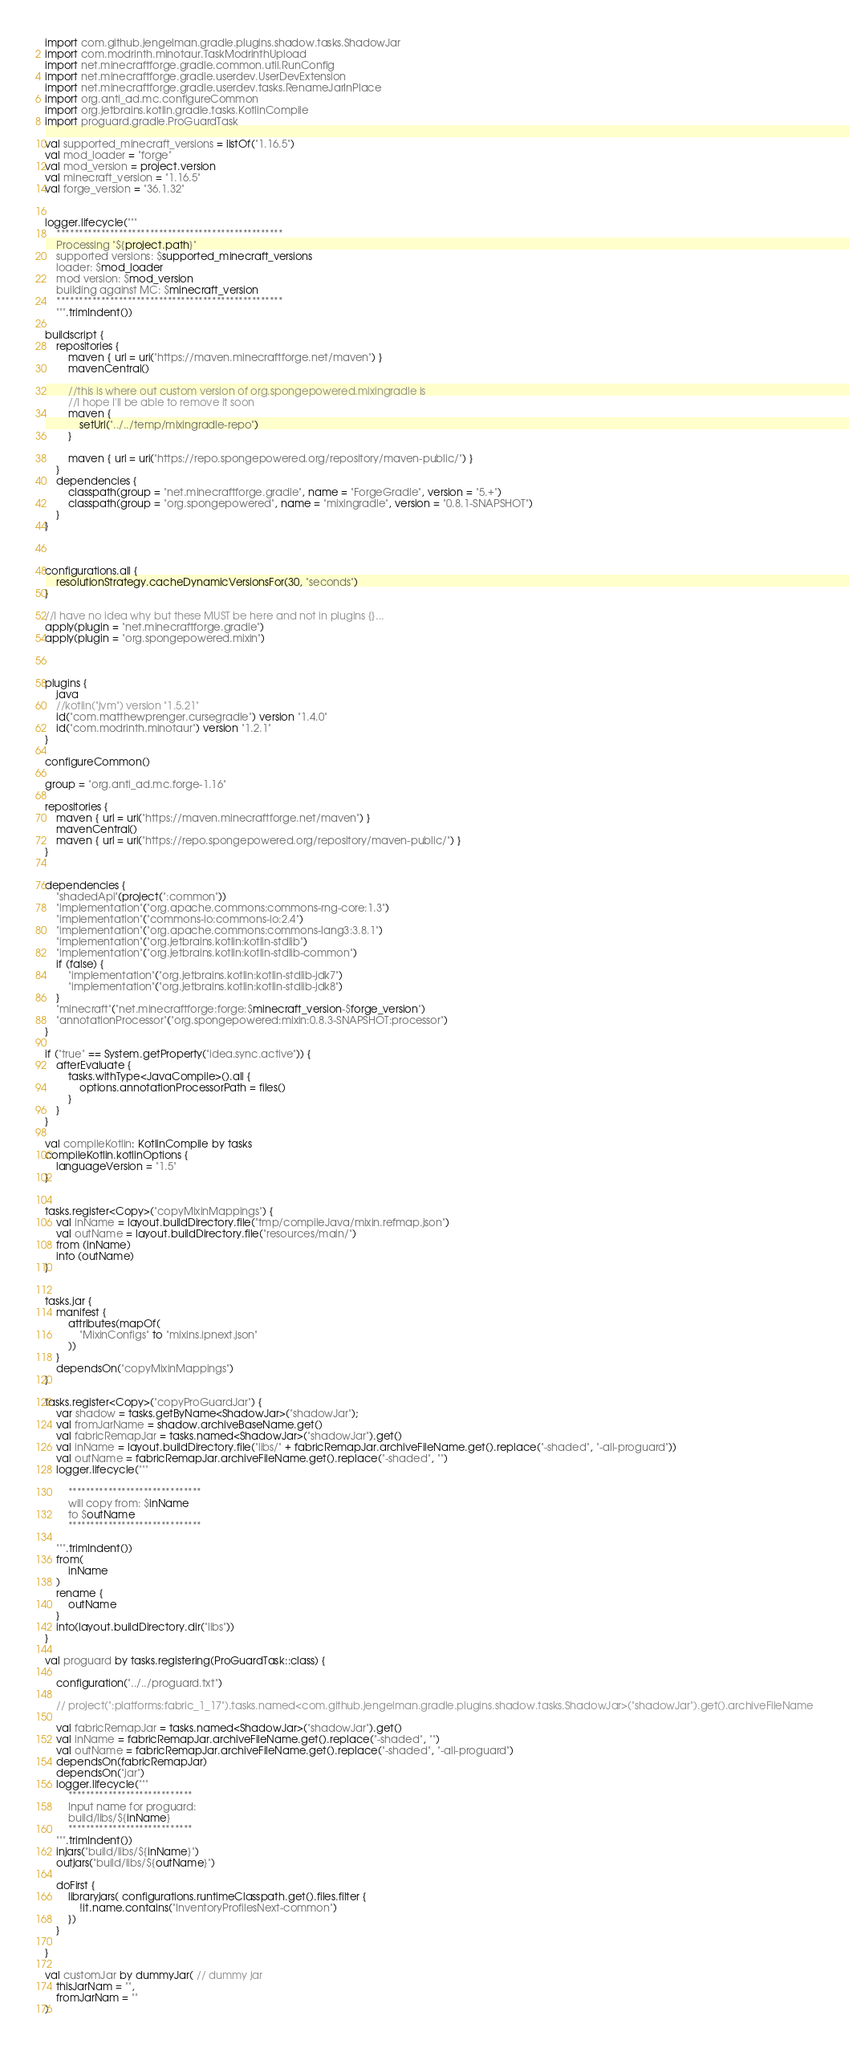<code> <loc_0><loc_0><loc_500><loc_500><_Kotlin_>import com.github.jengelman.gradle.plugins.shadow.tasks.ShadowJar
import com.modrinth.minotaur.TaskModrinthUpload
import net.minecraftforge.gradle.common.util.RunConfig
import net.minecraftforge.gradle.userdev.UserDevExtension
import net.minecraftforge.gradle.userdev.tasks.RenameJarInPlace
import org.anti_ad.mc.configureCommon
import org.jetbrains.kotlin.gradle.tasks.KotlinCompile
import proguard.gradle.ProGuardTask

val supported_minecraft_versions = listOf("1.16.5")
val mod_loader = "forge"
val mod_version = project.version
val minecraft_version = "1.16.5"
val forge_version = "36.1.32"


logger.lifecycle("""
    ***************************************************
    Processing "${project.path}"
    supported versions: $supported_minecraft_versions
    loader: $mod_loader
    mod version: $mod_version
    building against MC: $minecraft_version
    ***************************************************
    """.trimIndent())

buildscript {
    repositories {
        maven { url = uri("https://maven.minecraftforge.net/maven") }
        mavenCentral()

        //this is where out custom version of org.spongepowered.mixingradle is
        //I hope I'll be able to remove it soon
        maven {
            setUrl("../../temp/mixingradle-repo")
        }

        maven { url = uri("https://repo.spongepowered.org/repository/maven-public/") }
    }
    dependencies {
        classpath(group = "net.minecraftforge.gradle", name = "ForgeGradle", version = "5.+")
        classpath(group = "org.spongepowered", name = "mixingradle", version = "0.8.1-SNAPSHOT")
    }
}



configurations.all {
    resolutionStrategy.cacheDynamicVersionsFor(30, "seconds")
}

//I have no idea why but these MUST be here and not in plugins {}...
apply(plugin = "net.minecraftforge.gradle")
apply(plugin = "org.spongepowered.mixin")



plugins {
    java
    //kotlin("jvm") version "1.5.21"
    id("com.matthewprenger.cursegradle") version "1.4.0"
    id("com.modrinth.minotaur") version "1.2.1"
}

configureCommon()

group = "org.anti_ad.mc.forge-1.16"

repositories {
    maven { url = uri("https://maven.minecraftforge.net/maven") }
    mavenCentral()
    maven { url = uri("https://repo.spongepowered.org/repository/maven-public/") }
}


dependencies {
    "shadedApi"(project(":common"))
    "implementation"("org.apache.commons:commons-rng-core:1.3")
    "implementation"("commons-io:commons-io:2.4")
    "implementation"("org.apache.commons:commons-lang3:3.8.1")
    "implementation"("org.jetbrains.kotlin:kotlin-stdlib")
    "implementation"("org.jetbrains.kotlin:kotlin-stdlib-common")
    if (false) {
        "implementation"("org.jetbrains.kotlin:kotlin-stdlib-jdk7")
        "implementation"("org.jetbrains.kotlin:kotlin-stdlib-jdk8")
    }
    "minecraft"("net.minecraftforge:forge:$minecraft_version-$forge_version")
    "annotationProcessor"("org.spongepowered:mixin:0.8.3-SNAPSHOT:processor")
}

if ("true" == System.getProperty("idea.sync.active")) {
    afterEvaluate {
        tasks.withType<JavaCompile>().all {
            options.annotationProcessorPath = files()
        }
    }
}

val compileKotlin: KotlinCompile by tasks
compileKotlin.kotlinOptions {
    languageVersion = "1.5"
}


tasks.register<Copy>("copyMixinMappings") {
    val inName = layout.buildDirectory.file("tmp/compileJava/mixin.refmap.json")
    val outName = layout.buildDirectory.file("resources/main/")
    from (inName)
    into (outName)
}


tasks.jar {
    manifest {
        attributes(mapOf(
            "MixinConfigs" to "mixins.ipnext.json"
        ))
    }
    dependsOn("copyMixinMappings")
}

tasks.register<Copy>("copyProGuardJar") {
    var shadow = tasks.getByName<ShadowJar>("shadowJar");
    val fromJarName = shadow.archiveBaseName.get()
    val fabricRemapJar = tasks.named<ShadowJar>("shadowJar").get()
    val inName = layout.buildDirectory.file("libs/" + fabricRemapJar.archiveFileName.get().replace("-shaded", "-all-proguard"))
    val outName = fabricRemapJar.archiveFileName.get().replace("-shaded", "")
    logger.lifecycle("""
        
        ******************************
        will copy from: $inName
        to $outName
        ******************************
        
    """.trimIndent())
    from(
        inName
    )
    rename {
        outName
    }
    into(layout.buildDirectory.dir("libs"))
}

val proguard by tasks.registering(ProGuardTask::class) {

    configuration("../../proguard.txt")

    // project(":platforms:fabric_1_17").tasks.named<com.github.jengelman.gradle.plugins.shadow.tasks.ShadowJar>("shadowJar").get().archiveFileName

    val fabricRemapJar = tasks.named<ShadowJar>("shadowJar").get()
    val inName = fabricRemapJar.archiveFileName.get().replace("-shaded", "")
    val outName = fabricRemapJar.archiveFileName.get().replace("-shaded", "-all-proguard")
    dependsOn(fabricRemapJar)
    dependsOn("jar")
    logger.lifecycle(""" 
        ****************************
        Input name for proguard:
        build/libs/${inName}
        ****************************
    """.trimIndent())
    injars("build/libs/${inName}")
    outjars("build/libs/${outName}")

    doFirst {
        libraryjars( configurations.runtimeClasspath.get().files.filter {
            !it.name.contains("InventoryProfilesNext-common")
        })
    }

}

val customJar by dummyJar( // dummy jar
    thisJarNam = "",
    fromJarNam = ""
)
</code> 